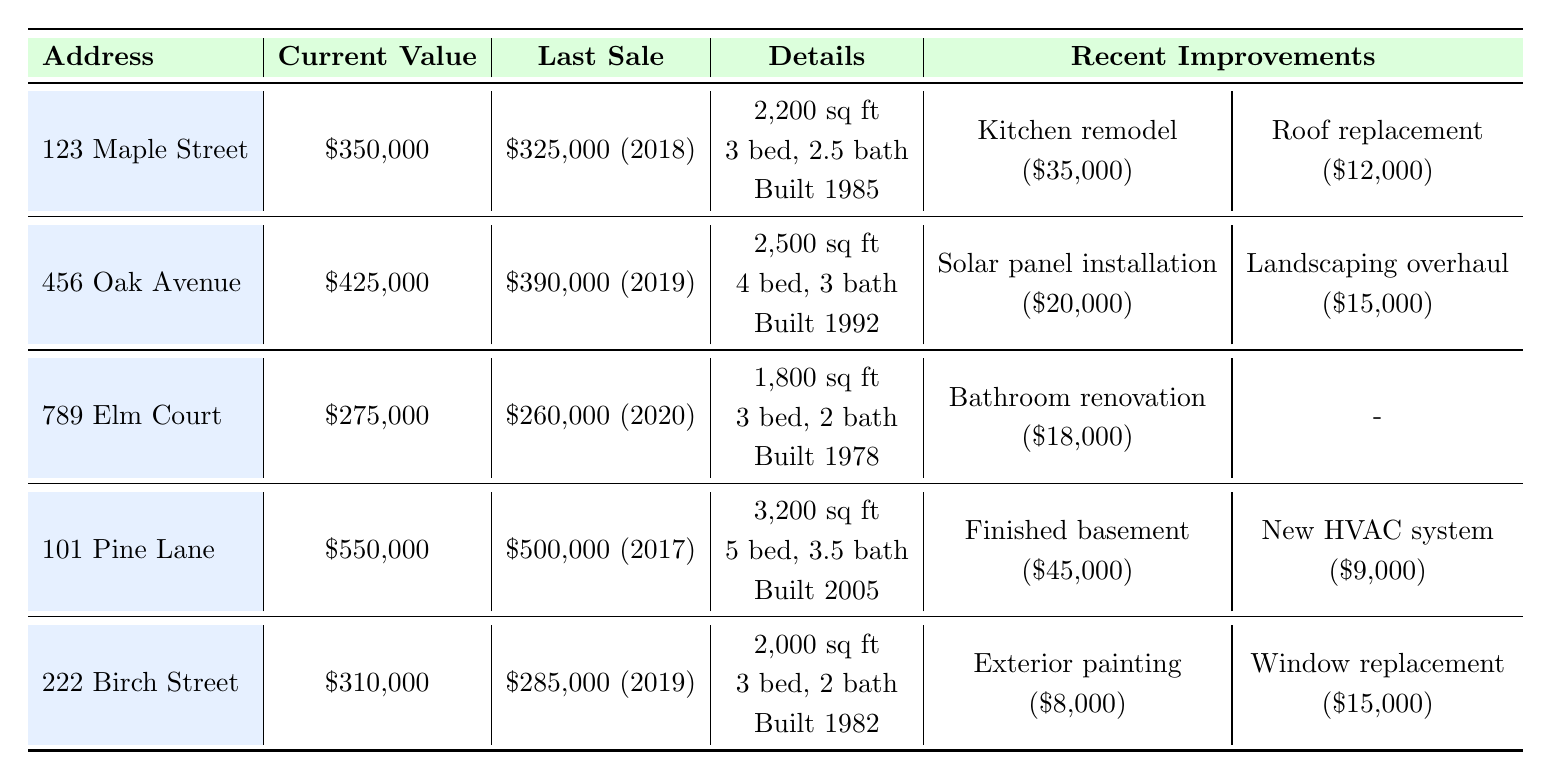What is the current value of 456 Oak Avenue? The current value of 456 Oak Avenue is listed directly in the table under the "Current Value" column. It shows \$425,000.
Answer: \$425,000 Which property has the highest current value? By looking at the "Current Value" column, 101 Pine Lane shows the highest value at \$550,000.
Answer: 101 Pine Lane How much did the kitchen remodel cost for 123 Maple Street? The cost for the kitchen remodel is listed under "Recent Improvements" for 123 Maple Street, which is \$35,000.
Answer: \$35,000 What is the difference between the last sale price and the current value of 789 Elm Court? The last sale price for 789 Elm Court is \$260,000 and the current value is \$275,000. The difference is \$275,000 - \$260,000 = \$15,000.
Answer: \$15,000 How many bedrooms does 101 Pine Lane have? The number of bedrooms for 101 Pine Lane is directly found in the "Details" section, where it states there are 5 bedrooms.
Answer: 5 bedrooms What is the total cost of recent improvements for 222 Birch Street? The recent improvements for 222 Birch Street include exterior painting for \$8,000 and window replacement for \$15,000. The total cost can be calculated as \$8,000 + \$15,000 = \$23,000.
Answer: \$23,000 Did 789 Elm Court have any recent improvements? The "Recent Improvements" section for 789 Elm Court shows it had a bathroom renovation costing \$18,000, so the statement is true.
Answer: Yes Which property underwent a roof replacement and when was it completed? Referring to the "Recent Improvements" for 123 Maple Street, it shows a roof replacement was completed on 2020-06-22.
Answer: 123 Maple Street, completed on 2020-06-22 What is the average square footage of all properties listed? The square footages are 2200, 2500, 1800, 3200, and 2000, which sum to 2200 + 2500 + 1800 + 3200 + 2000 = 11700. Dividing by 5 gives an average of \$11,700 / 5 = 2340 sq ft.
Answer: 2340 sq ft Which property had the lowest current value among those listed? The current values are \$350,000, \$425,000, \$275,000, \$550,000, and \$310,000. The lowest value among these is for 789 Elm Court at \$275,000.
Answer: 789 Elm Court 